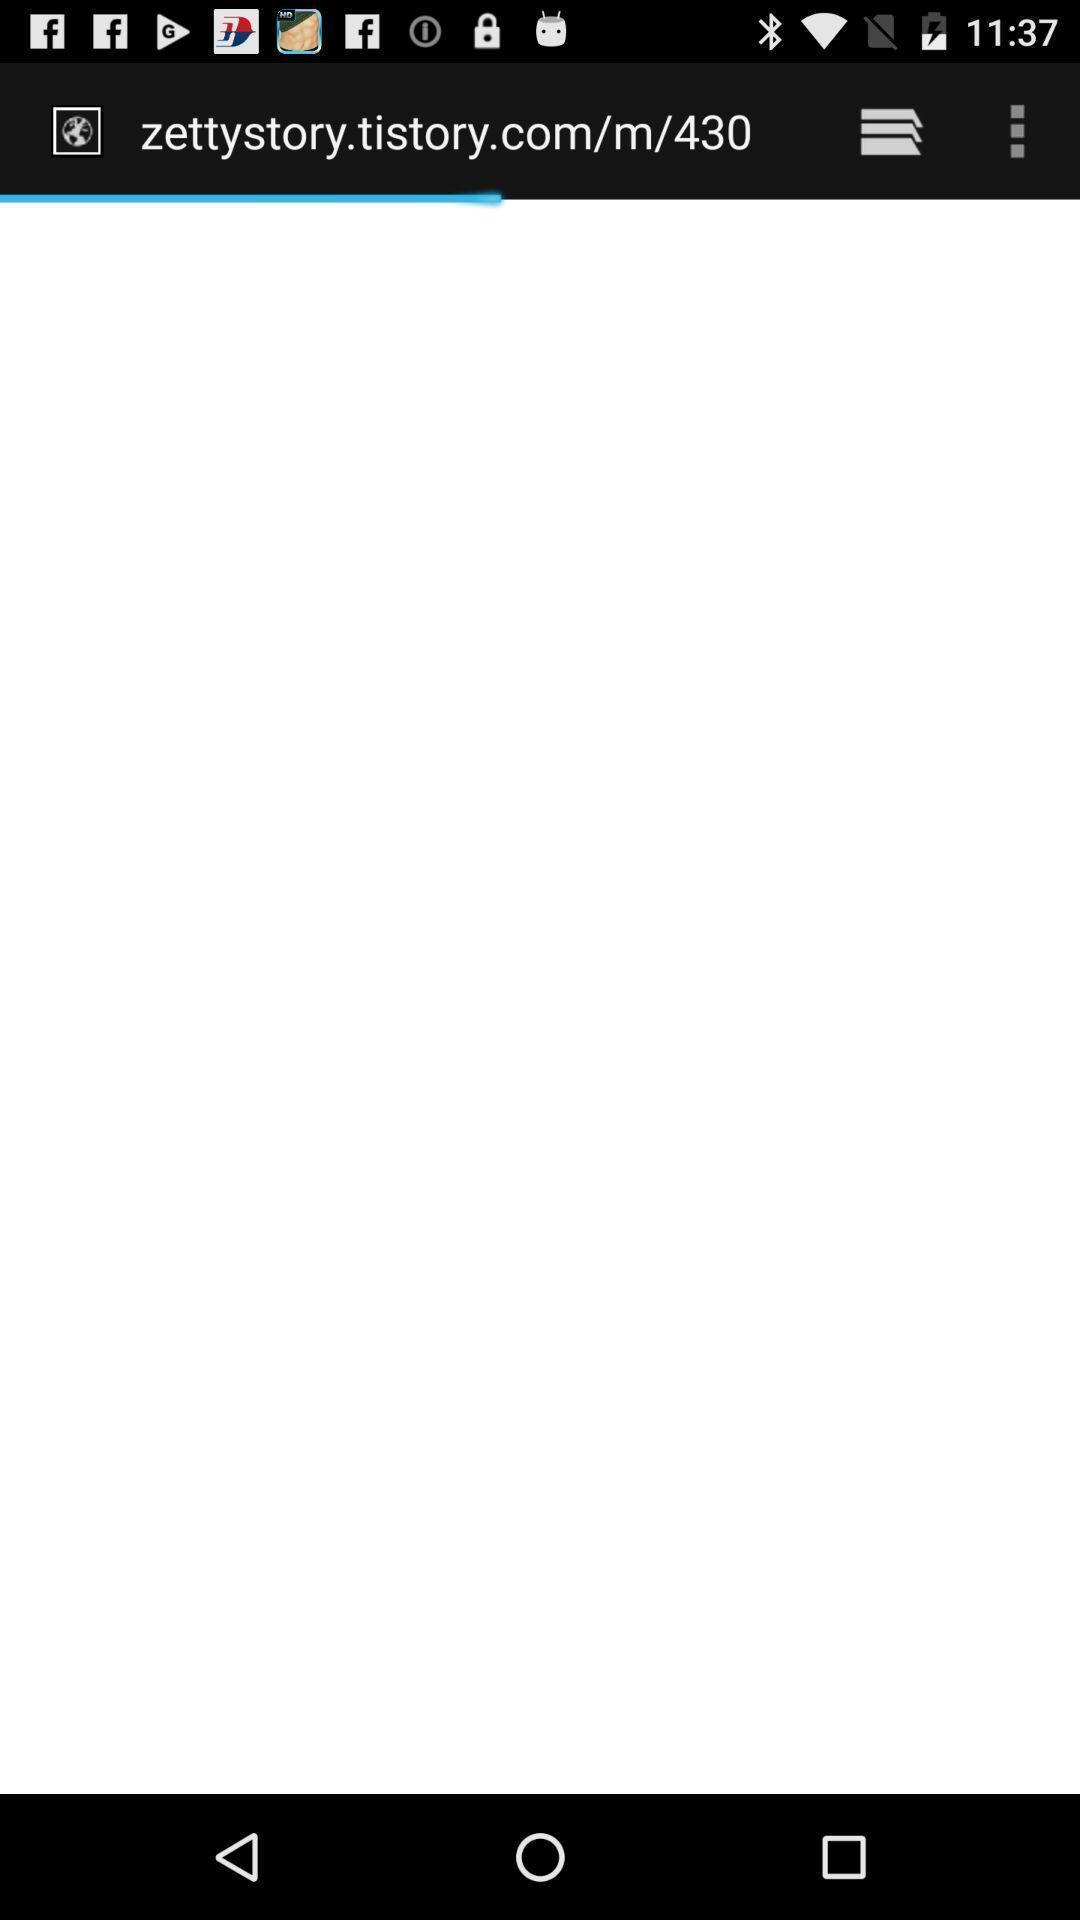Tell me what you see in this picture. Page displaying a browsing window. 